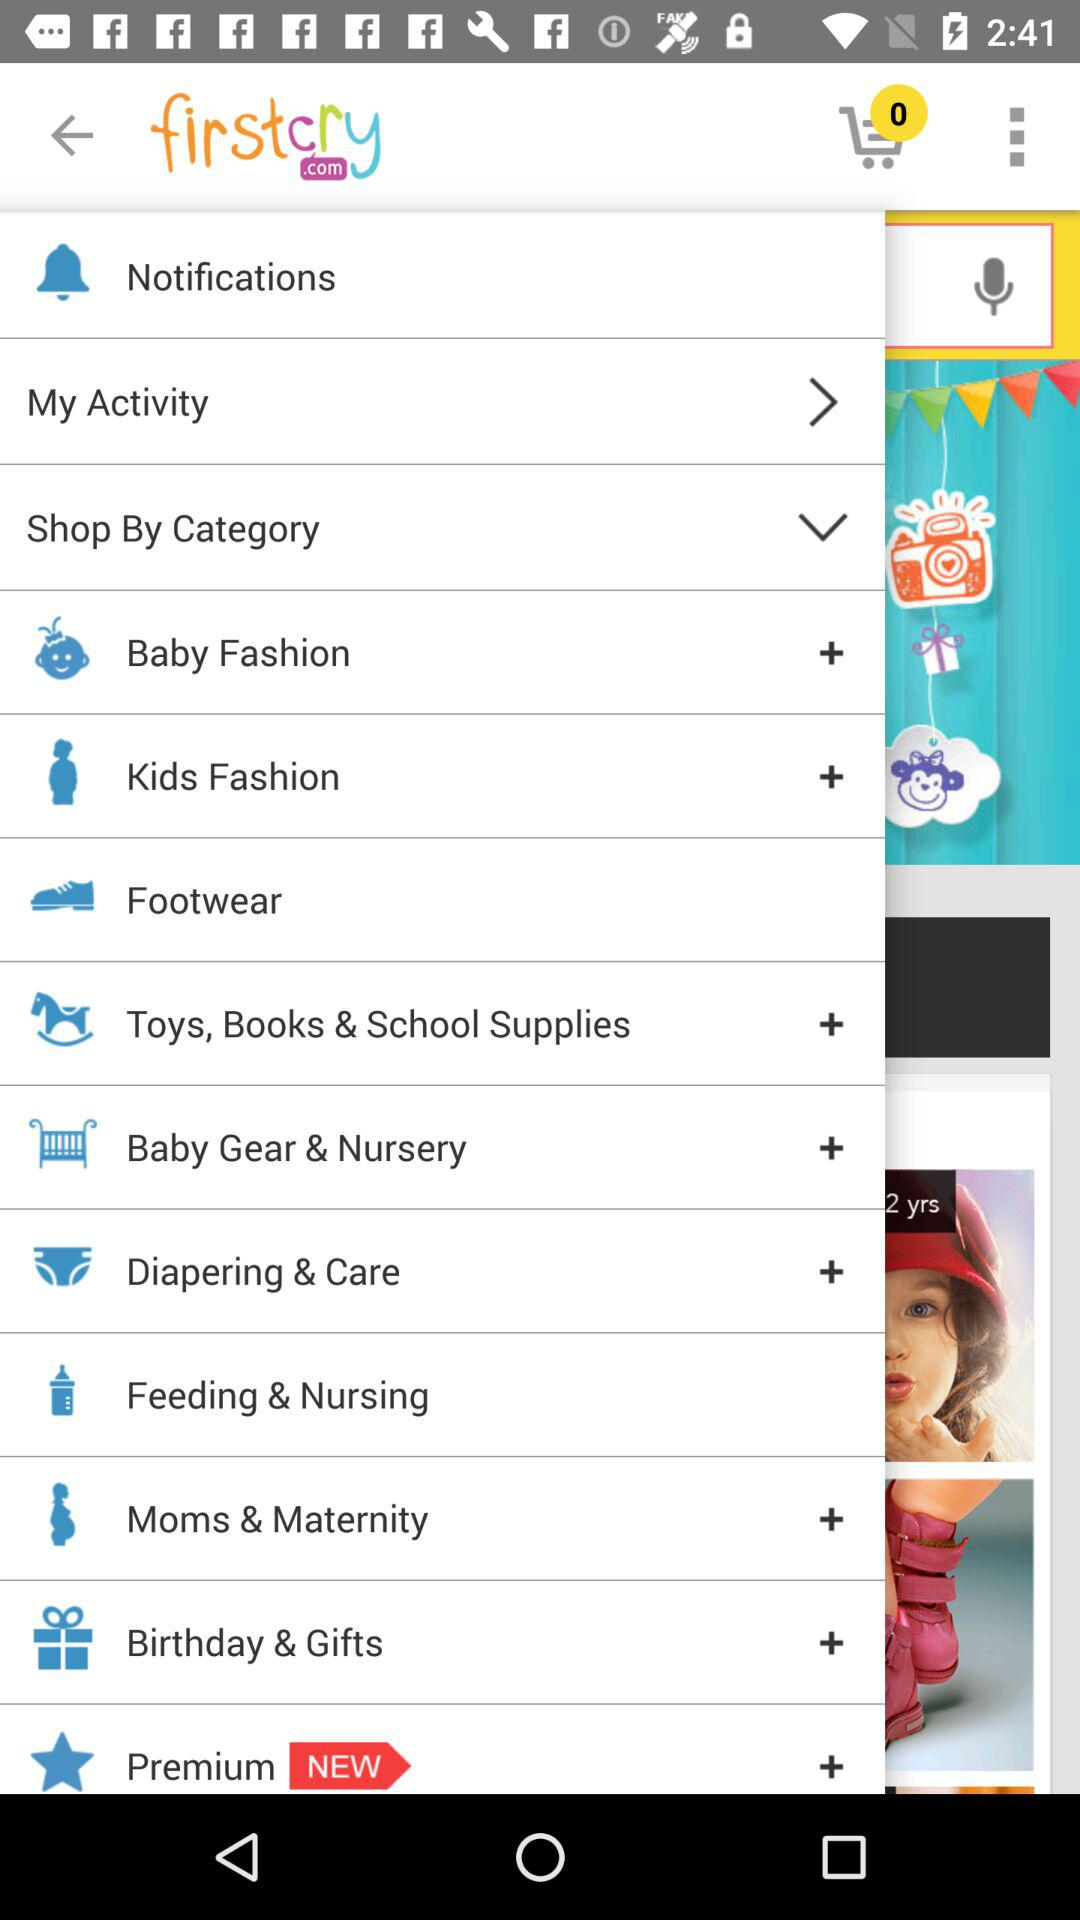How many items are in the cart? There are 0 items in the cart. 